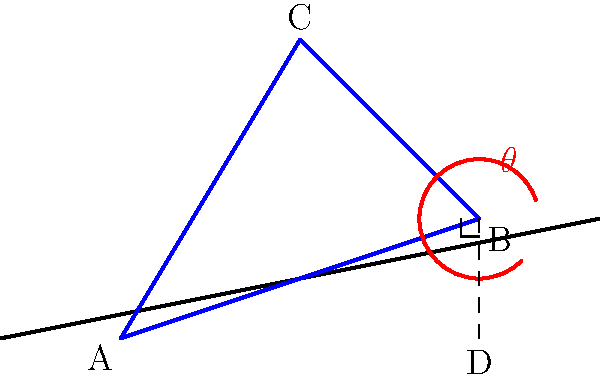You're setting up camp on a hillside. The ground slopes at an angle, and you need to determine the optimal angle $\theta$ for your tent pole (BC in the diagram) to ensure it's perpendicular to the ground. Given that the horizontal distance between the tent poles (AD) is 60 feet and the height difference (BD) is 20 feet, what is the optimal angle $\theta$ for the tent pole? Let's approach this step-by-step:

1) First, we need to identify the right triangle formed by the ground and the vertical line from point B to D.

2) In this right triangle ABD:
   - The base (AD) is 60 feet
   - The height (BD) is 20 feet

3) We can find the angle of the slope using the arctangent function:
   $$\text{Slope angle} = \arctan(\frac{\text{opposite}}{\text{adjacent}}) = \arctan(\frac{20}{60})$$

4) Simplify the fraction:
   $$\text{Slope angle} = \arctan(\frac{1}{3})$$

5) Calculate this angle:
   $$\text{Slope angle} \approx 18.43^\circ$$

6) For the tent pole to be perpendicular to the ground, it must form a right angle (90°) with the slope.

7) Therefore, the optimal angle $\theta$ for the tent pole is:
   $$\theta = 90^\circ - 18.43^\circ = 71.57^\circ$$

Thus, the optimal angle for the tent pole is approximately 71.57° from the horizontal.
Answer: $71.57^\circ$ 